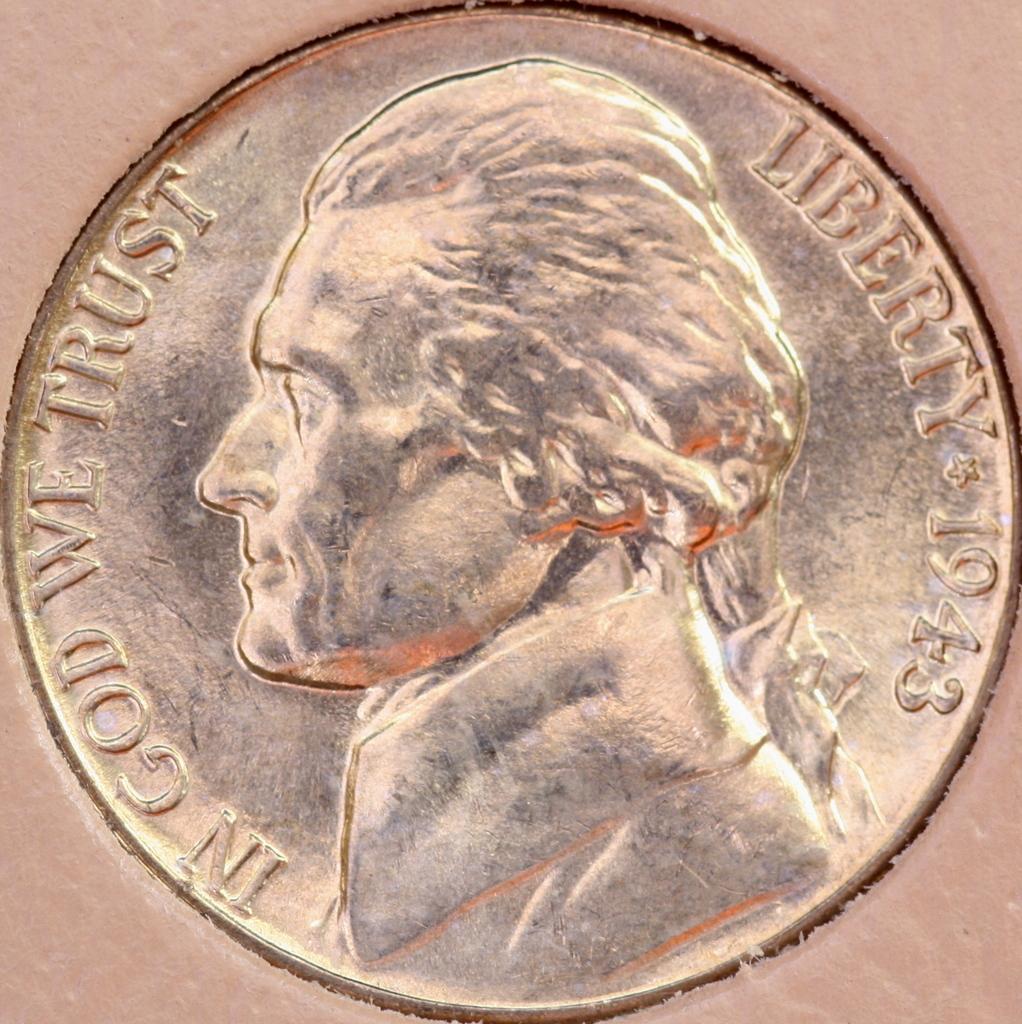What year was this coin made?
Offer a very short reply. 1943. In whom should we trust?
Provide a short and direct response. God. 